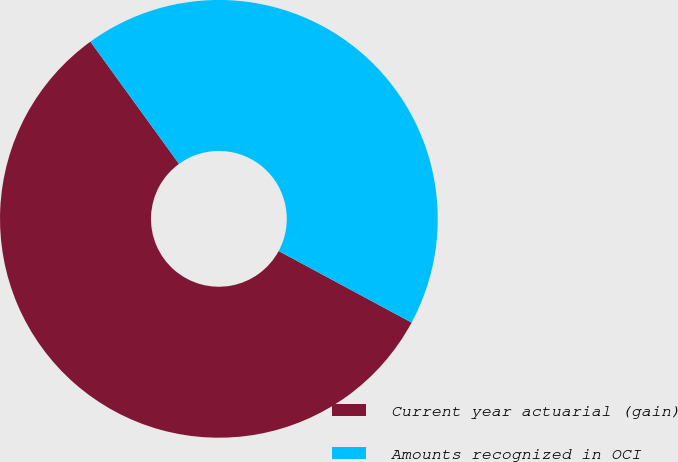Convert chart. <chart><loc_0><loc_0><loc_500><loc_500><pie_chart><fcel>Current year actuarial (gain)<fcel>Amounts recognized in OCI<nl><fcel>57.16%<fcel>42.84%<nl></chart> 